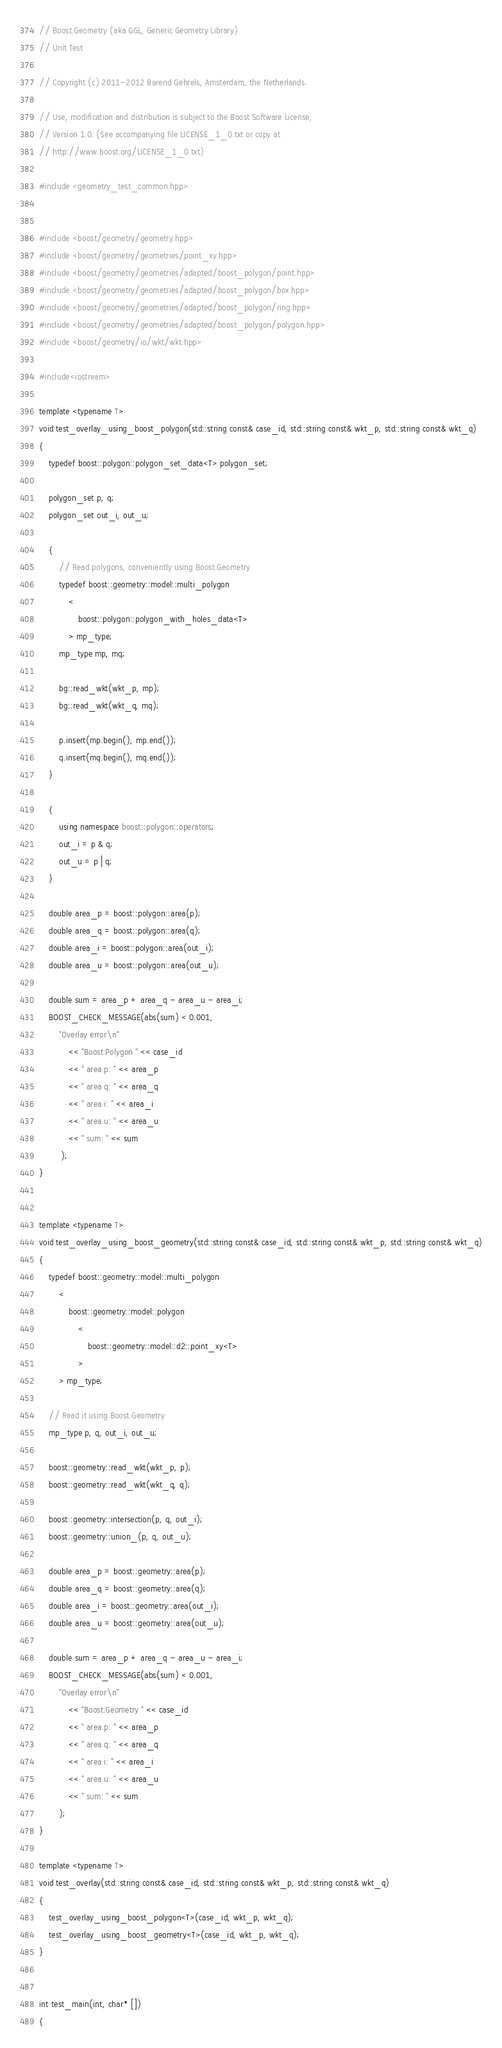<code> <loc_0><loc_0><loc_500><loc_500><_C++_>// Boost.Geometry (aka GGL, Generic Geometry Library)
// Unit Test

// Copyright (c) 2011-2012 Barend Gehrels, Amsterdam, the Netherlands.

// Use, modification and distribution is subject to the Boost Software License,
// Version 1.0. (See accompanying file LICENSE_1_0.txt or copy at
// http://www.boost.org/LICENSE_1_0.txt)

#include <geometry_test_common.hpp>


#include <boost/geometry/geometry.hpp>
#include <boost/geometry/geometries/point_xy.hpp>
#include <boost/geometry/geometries/adapted/boost_polygon/point.hpp>
#include <boost/geometry/geometries/adapted/boost_polygon/box.hpp>
#include <boost/geometry/geometries/adapted/boost_polygon/ring.hpp>
#include <boost/geometry/geometries/adapted/boost_polygon/polygon.hpp>
#include <boost/geometry/io/wkt/wkt.hpp>

#include<iostream>

template <typename T>
void test_overlay_using_boost_polygon(std::string const& case_id, std::string const& wkt_p, std::string const& wkt_q)
{
    typedef boost::polygon::polygon_set_data<T> polygon_set;

    polygon_set p, q;
    polygon_set out_i, out_u;

    {
        // Read polygons, conveniently using Boost.Geometry
        typedef boost::geometry::model::multi_polygon
            <
                boost::polygon::polygon_with_holes_data<T>
            > mp_type;
        mp_type mp, mq;

        bg::read_wkt(wkt_p, mp);
        bg::read_wkt(wkt_q, mq);

        p.insert(mp.begin(), mp.end());
        q.insert(mq.begin(), mq.end());
    }

    {
        using namespace boost::polygon::operators;
        out_i = p & q;
        out_u = p | q;
    }

    double area_p = boost::polygon::area(p);
    double area_q = boost::polygon::area(q);
    double area_i = boost::polygon::area(out_i);
    double area_u = boost::polygon::area(out_u);

    double sum = area_p + area_q - area_u - area_i;
    BOOST_CHECK_MESSAGE(abs(sum) < 0.001,
        "Overlay error\n"
            << "Boost.Polygon " << case_id
            << " area p: " << area_p
            << " area q: " << area_q
            << " area i: " << area_i
            << " area u: " << area_u
            << " sum: " << sum
         );
}


template <typename T>
void test_overlay_using_boost_geometry(std::string const& case_id, std::string const& wkt_p, std::string const& wkt_q)
{
    typedef boost::geometry::model::multi_polygon
        <
            boost::geometry::model::polygon
                <
                    boost::geometry::model::d2::point_xy<T>
                >
        > mp_type;

    // Read it using Boost.Geometry
    mp_type p, q, out_i, out_u;

    boost::geometry::read_wkt(wkt_p, p);
    boost::geometry::read_wkt(wkt_q, q);

    boost::geometry::intersection(p, q, out_i);
    boost::geometry::union_(p, q, out_u);

    double area_p = boost::geometry::area(p);
    double area_q = boost::geometry::area(q);
    double area_i = boost::geometry::area(out_i);
    double area_u = boost::geometry::area(out_u);

    double sum = area_p + area_q - area_u - area_i;
    BOOST_CHECK_MESSAGE(abs(sum) < 0.001,
        "Overlay error\n"
            << "Boost.Geometry " << case_id
            << " area p: " << area_p
            << " area q: " << area_q
            << " area i: " << area_i
            << " area u: " << area_u
            << " sum: " << sum
        );
}

template <typename T>
void test_overlay(std::string const& case_id, std::string const& wkt_p, std::string const& wkt_q)
{
    test_overlay_using_boost_polygon<T>(case_id, wkt_p, wkt_q);
    test_overlay_using_boost_geometry<T>(case_id, wkt_p, wkt_q);
}


int test_main(int, char* [])
{</code> 